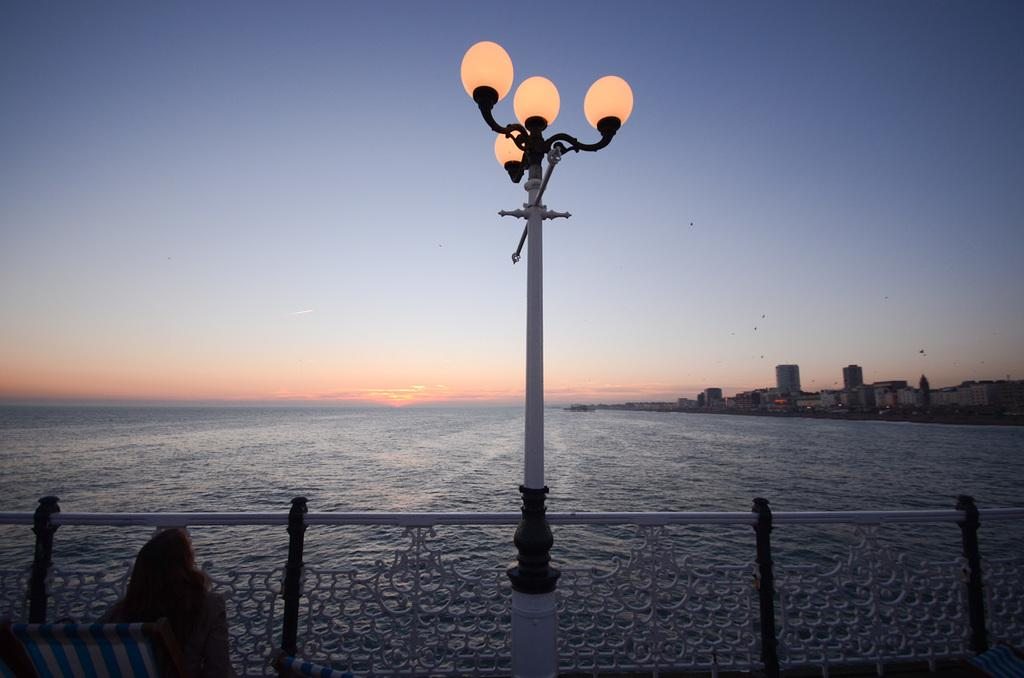What is present in the image? There is a person in the image. What can be seen in the background of the image? There is a pole, lights, water, and buildings in the background of the image. What is the color of the sky in the image? The sky is blue, white, and orange in color. Can you see any trucks or cables in the image? There is no truck or cable present in the image. Is there a harbor visible in the image? There is no harbor visible in the image. 